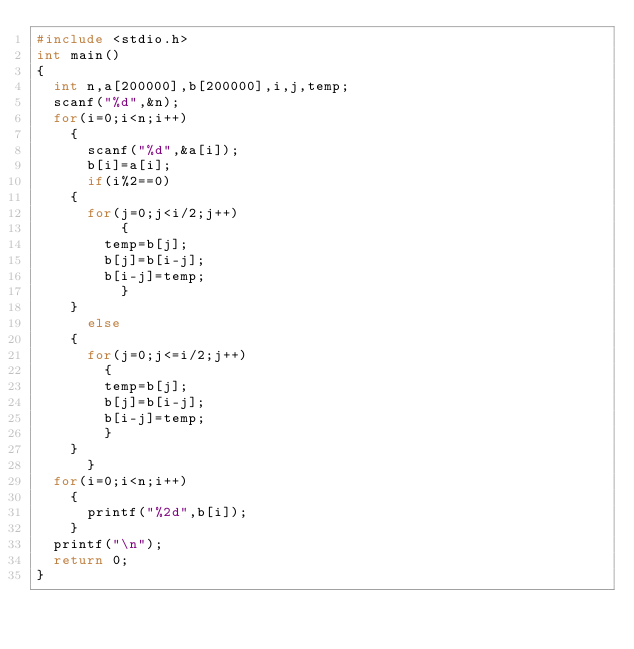<code> <loc_0><loc_0><loc_500><loc_500><_C_>#include <stdio.h>
int main()
{
  int n,a[200000],b[200000],i,j,temp;
  scanf("%d",&n);
  for(i=0;i<n;i++)
    {
      scanf("%d",&a[i]);
      b[i]=a[i];
      if(i%2==0)
	{
	  for(j=0;j<i/2;j++)
	      {
		temp=b[j];
		b[j]=b[i-j];
		b[i-j]=temp;
	      }
	}
      else
	{
	  for(j=0;j<=i/2;j++)
	    {
		temp=b[j];
		b[j]=b[i-j];
		b[i-j]=temp;
	    }
	}
      }
  for(i=0;i<n;i++)
    {
      printf("%2d",b[i]);
    }
  printf("\n");
  return 0;
}
  
</code> 